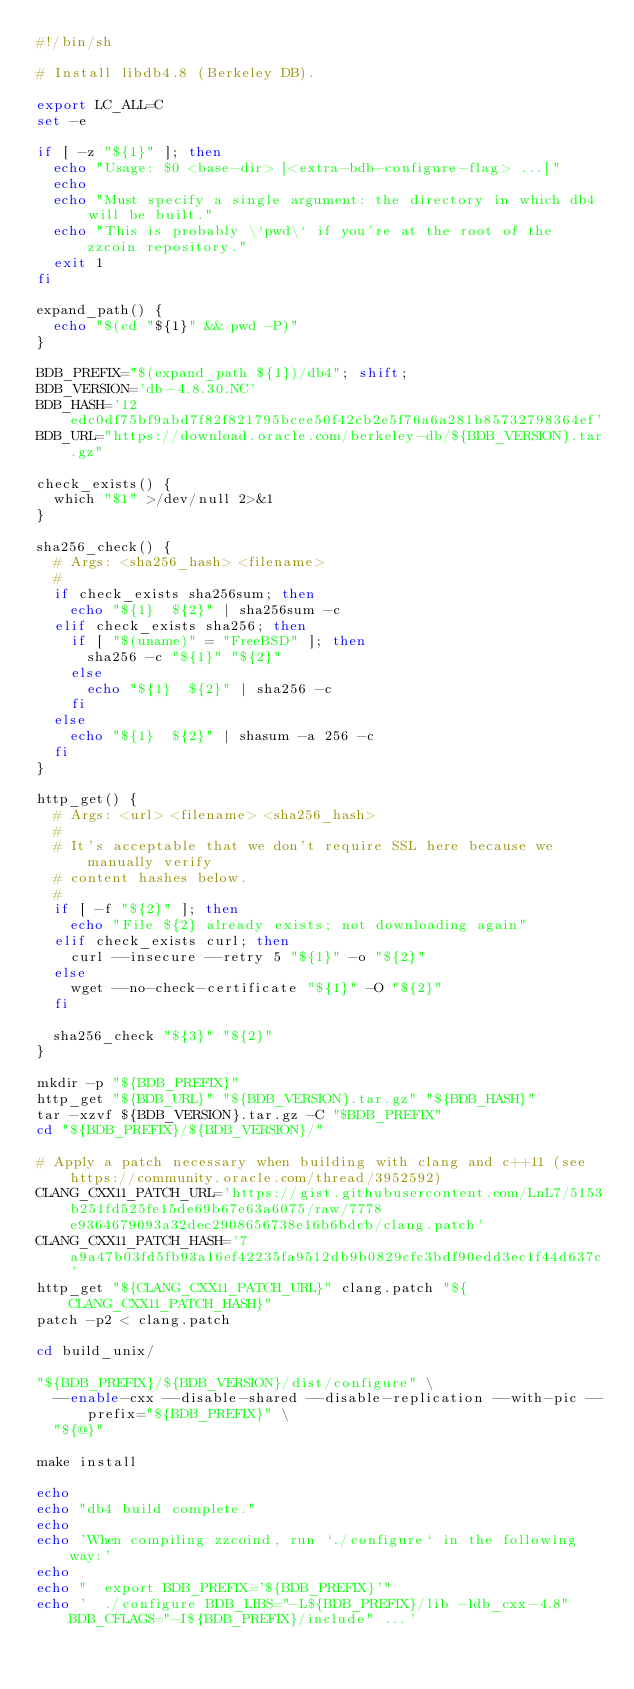<code> <loc_0><loc_0><loc_500><loc_500><_Bash_>#!/bin/sh

# Install libdb4.8 (Berkeley DB).

export LC_ALL=C
set -e

if [ -z "${1}" ]; then
  echo "Usage: $0 <base-dir> [<extra-bdb-configure-flag> ...]"
  echo
  echo "Must specify a single argument: the directory in which db4 will be built."
  echo "This is probably \`pwd\` if you're at the root of the zzcoin repository."
  exit 1
fi

expand_path() {
  echo "$(cd "${1}" && pwd -P)"
}

BDB_PREFIX="$(expand_path ${1})/db4"; shift;
BDB_VERSION='db-4.8.30.NC'
BDB_HASH='12edc0df75bf9abd7f82f821795bcee50f42cb2e5f76a6a281b85732798364ef'
BDB_URL="https://download.oracle.com/berkeley-db/${BDB_VERSION}.tar.gz"

check_exists() {
  which "$1" >/dev/null 2>&1
}

sha256_check() {
  # Args: <sha256_hash> <filename>
  #
  if check_exists sha256sum; then
    echo "${1}  ${2}" | sha256sum -c
  elif check_exists sha256; then
    if [ "$(uname)" = "FreeBSD" ]; then
      sha256 -c "${1}" "${2}"
    else
      echo "${1}  ${2}" | sha256 -c
    fi
  else
    echo "${1}  ${2}" | shasum -a 256 -c
  fi
}

http_get() {
  # Args: <url> <filename> <sha256_hash>
  #
  # It's acceptable that we don't require SSL here because we manually verify
  # content hashes below.
  #
  if [ -f "${2}" ]; then
    echo "File ${2} already exists; not downloading again"
  elif check_exists curl; then
    curl --insecure --retry 5 "${1}" -o "${2}"
  else
    wget --no-check-certificate "${1}" -O "${2}"
  fi

  sha256_check "${3}" "${2}"
}

mkdir -p "${BDB_PREFIX}"
http_get "${BDB_URL}" "${BDB_VERSION}.tar.gz" "${BDB_HASH}"
tar -xzvf ${BDB_VERSION}.tar.gz -C "$BDB_PREFIX"
cd "${BDB_PREFIX}/${BDB_VERSION}/"

# Apply a patch necessary when building with clang and c++11 (see https://community.oracle.com/thread/3952592)
CLANG_CXX11_PATCH_URL='https://gist.githubusercontent.com/LnL7/5153b251fd525fe15de69b67e63a6075/raw/7778e9364679093a32dec2908656738e16b6bdcb/clang.patch'
CLANG_CXX11_PATCH_HASH='7a9a47b03fd5fb93a16ef42235fa9512db9b0829cfc3bdf90edd3ec1f44d637c'
http_get "${CLANG_CXX11_PATCH_URL}" clang.patch "${CLANG_CXX11_PATCH_HASH}"
patch -p2 < clang.patch

cd build_unix/

"${BDB_PREFIX}/${BDB_VERSION}/dist/configure" \
  --enable-cxx --disable-shared --disable-replication --with-pic --prefix="${BDB_PREFIX}" \
  "${@}"

make install

echo
echo "db4 build complete."
echo
echo 'When compiling zzcoind, run `./configure` in the following way:'
echo
echo "  export BDB_PREFIX='${BDB_PREFIX}'"
echo '  ./configure BDB_LIBS="-L${BDB_PREFIX}/lib -ldb_cxx-4.8" BDB_CFLAGS="-I${BDB_PREFIX}/include" ...'
</code> 